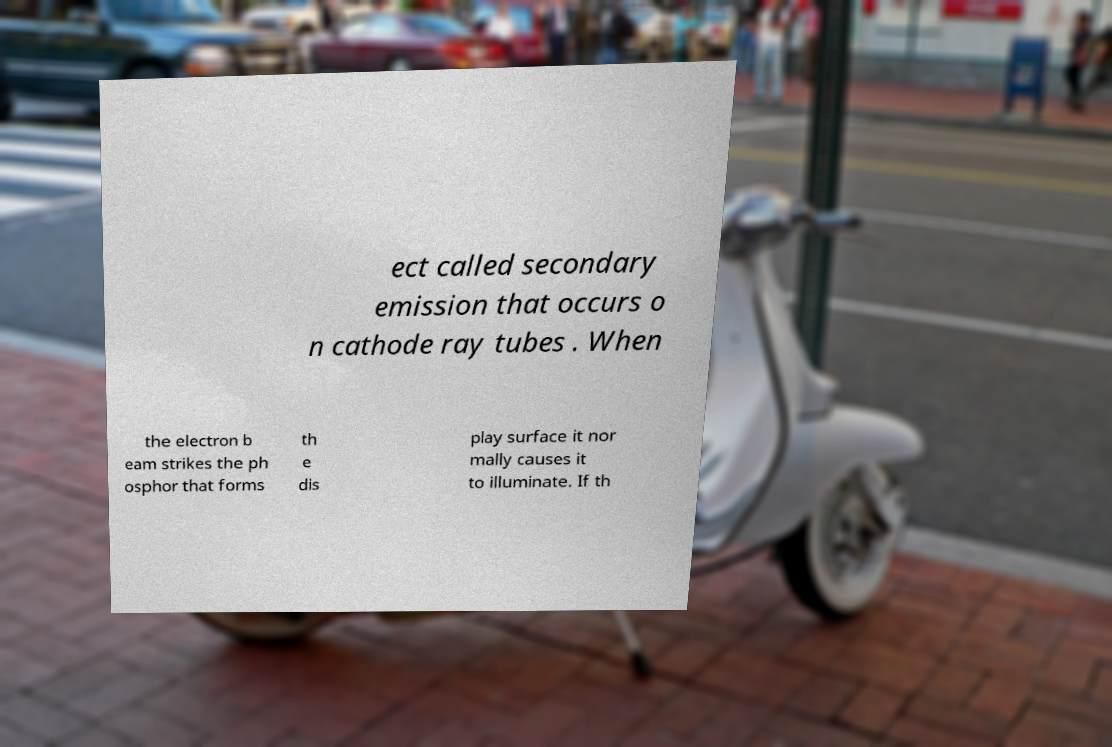Could you extract and type out the text from this image? ect called secondary emission that occurs o n cathode ray tubes . When the electron b eam strikes the ph osphor that forms th e dis play surface it nor mally causes it to illuminate. If th 